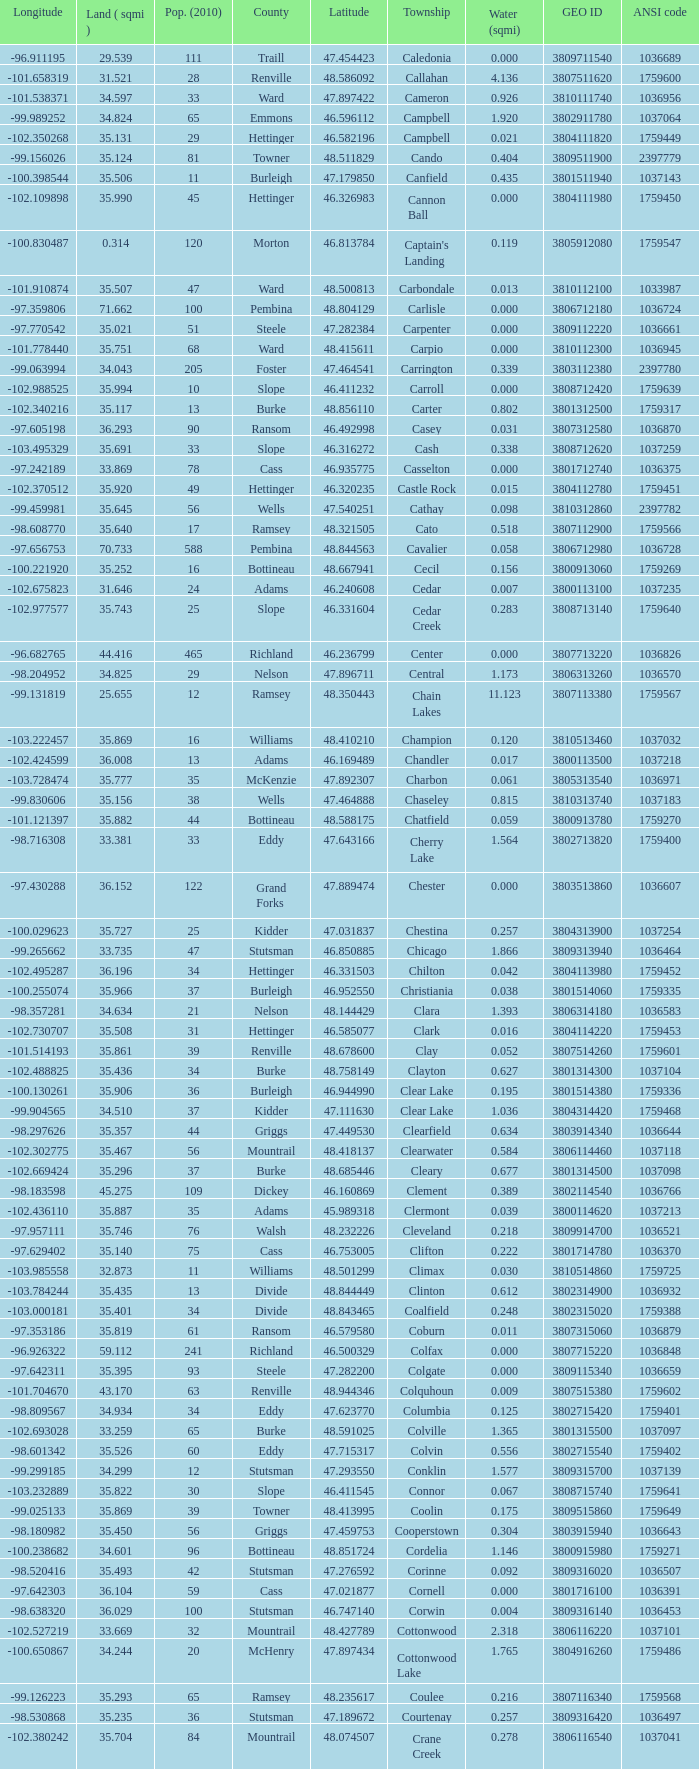What was the latitude of the Clearwater townsship? 48.418137. Can you parse all the data within this table? {'header': ['Longitude', 'Land ( sqmi )', 'Pop. (2010)', 'County', 'Latitude', 'Township', 'Water (sqmi)', 'GEO ID', 'ANSI code'], 'rows': [['-96.911195', '29.539', '111', 'Traill', '47.454423', 'Caledonia', '0.000', '3809711540', '1036689'], ['-101.658319', '31.521', '28', 'Renville', '48.586092', 'Callahan', '4.136', '3807511620', '1759600'], ['-101.538371', '34.597', '33', 'Ward', '47.897422', 'Cameron', '0.926', '3810111740', '1036956'], ['-99.989252', '34.824', '65', 'Emmons', '46.596112', 'Campbell', '1.920', '3802911780', '1037064'], ['-102.350268', '35.131', '29', 'Hettinger', '46.582196', 'Campbell', '0.021', '3804111820', '1759449'], ['-99.156026', '35.124', '81', 'Towner', '48.511829', 'Cando', '0.404', '3809511900', '2397779'], ['-100.398544', '35.506', '11', 'Burleigh', '47.179850', 'Canfield', '0.435', '3801511940', '1037143'], ['-102.109898', '35.990', '45', 'Hettinger', '46.326983', 'Cannon Ball', '0.000', '3804111980', '1759450'], ['-100.830487', '0.314', '120', 'Morton', '46.813784', "Captain's Landing", '0.119', '3805912080', '1759547'], ['-101.910874', '35.507', '47', 'Ward', '48.500813', 'Carbondale', '0.013', '3810112100', '1033987'], ['-97.359806', '71.662', '100', 'Pembina', '48.804129', 'Carlisle', '0.000', '3806712180', '1036724'], ['-97.770542', '35.021', '51', 'Steele', '47.282384', 'Carpenter', '0.000', '3809112220', '1036661'], ['-101.778440', '35.751', '68', 'Ward', '48.415611', 'Carpio', '0.000', '3810112300', '1036945'], ['-99.063994', '34.043', '205', 'Foster', '47.464541', 'Carrington', '0.339', '3803112380', '2397780'], ['-102.988525', '35.994', '10', 'Slope', '46.411232', 'Carroll', '0.000', '3808712420', '1759639'], ['-102.340216', '35.117', '13', 'Burke', '48.856110', 'Carter', '0.802', '3801312500', '1759317'], ['-97.605198', '36.293', '90', 'Ransom', '46.492998', 'Casey', '0.031', '3807312580', '1036870'], ['-103.495329', '35.691', '33', 'Slope', '46.316272', 'Cash', '0.338', '3808712620', '1037259'], ['-97.242189', '33.869', '78', 'Cass', '46.935775', 'Casselton', '0.000', '3801712740', '1036375'], ['-102.370512', '35.920', '49', 'Hettinger', '46.320235', 'Castle Rock', '0.015', '3804112780', '1759451'], ['-99.459981', '35.645', '56', 'Wells', '47.540251', 'Cathay', '0.098', '3810312860', '2397782'], ['-98.608770', '35.640', '17', 'Ramsey', '48.321505', 'Cato', '0.518', '3807112900', '1759566'], ['-97.656753', '70.733', '588', 'Pembina', '48.844563', 'Cavalier', '0.058', '3806712980', '1036728'], ['-100.221920', '35.252', '16', 'Bottineau', '48.667941', 'Cecil', '0.156', '3800913060', '1759269'], ['-102.675823', '31.646', '24', 'Adams', '46.240608', 'Cedar', '0.007', '3800113100', '1037235'], ['-102.977577', '35.743', '25', 'Slope', '46.331604', 'Cedar Creek', '0.283', '3808713140', '1759640'], ['-96.682765', '44.416', '465', 'Richland', '46.236799', 'Center', '0.000', '3807713220', '1036826'], ['-98.204952', '34.825', '29', 'Nelson', '47.896711', 'Central', '1.173', '3806313260', '1036570'], ['-99.131819', '25.655', '12', 'Ramsey', '48.350443', 'Chain Lakes', '11.123', '3807113380', '1759567'], ['-103.222457', '35.869', '16', 'Williams', '48.410210', 'Champion', '0.120', '3810513460', '1037032'], ['-102.424599', '36.008', '13', 'Adams', '46.169489', 'Chandler', '0.017', '3800113500', '1037218'], ['-103.728474', '35.777', '35', 'McKenzie', '47.892307', 'Charbon', '0.061', '3805313540', '1036971'], ['-99.830606', '35.156', '38', 'Wells', '47.464888', 'Chaseley', '0.815', '3810313740', '1037183'], ['-101.121397', '35.882', '44', 'Bottineau', '48.588175', 'Chatfield', '0.059', '3800913780', '1759270'], ['-98.716308', '33.381', '33', 'Eddy', '47.643166', 'Cherry Lake', '1.564', '3802713820', '1759400'], ['-97.430288', '36.152', '122', 'Grand Forks', '47.889474', 'Chester', '0.000', '3803513860', '1036607'], ['-100.029623', '35.727', '25', 'Kidder', '47.031837', 'Chestina', '0.257', '3804313900', '1037254'], ['-99.265662', '33.735', '47', 'Stutsman', '46.850885', 'Chicago', '1.866', '3809313940', '1036464'], ['-102.495287', '36.196', '34', 'Hettinger', '46.331503', 'Chilton', '0.042', '3804113980', '1759452'], ['-100.255074', '35.966', '37', 'Burleigh', '46.952550', 'Christiania', '0.038', '3801514060', '1759335'], ['-98.357281', '34.634', '21', 'Nelson', '48.144429', 'Clara', '1.393', '3806314180', '1036583'], ['-102.730707', '35.508', '31', 'Hettinger', '46.585077', 'Clark', '0.016', '3804114220', '1759453'], ['-101.514193', '35.861', '39', 'Renville', '48.678600', 'Clay', '0.052', '3807514260', '1759601'], ['-102.488825', '35.436', '34', 'Burke', '48.758149', 'Clayton', '0.627', '3801314300', '1037104'], ['-100.130261', '35.906', '36', 'Burleigh', '46.944990', 'Clear Lake', '0.195', '3801514380', '1759336'], ['-99.904565', '34.510', '37', 'Kidder', '47.111630', 'Clear Lake', '1.036', '3804314420', '1759468'], ['-98.297626', '35.357', '44', 'Griggs', '47.449530', 'Clearfield', '0.634', '3803914340', '1036644'], ['-102.302775', '35.467', '56', 'Mountrail', '48.418137', 'Clearwater', '0.584', '3806114460', '1037118'], ['-102.669424', '35.296', '37', 'Burke', '48.685446', 'Cleary', '0.677', '3801314500', '1037098'], ['-98.183598', '45.275', '109', 'Dickey', '46.160869', 'Clement', '0.389', '3802114540', '1036766'], ['-102.436110', '35.887', '35', 'Adams', '45.989318', 'Clermont', '0.039', '3800114620', '1037213'], ['-97.957111', '35.746', '76', 'Walsh', '48.232226', 'Cleveland', '0.218', '3809914700', '1036521'], ['-97.629402', '35.140', '75', 'Cass', '46.753005', 'Clifton', '0.222', '3801714780', '1036370'], ['-103.985558', '32.873', '11', 'Williams', '48.501299', 'Climax', '0.030', '3810514860', '1759725'], ['-103.784244', '35.435', '13', 'Divide', '48.844449', 'Clinton', '0.612', '3802314900', '1036932'], ['-103.000181', '35.401', '34', 'Divide', '48.843465', 'Coalfield', '0.248', '3802315020', '1759388'], ['-97.353186', '35.819', '61', 'Ransom', '46.579580', 'Coburn', '0.011', '3807315060', '1036879'], ['-96.926322', '59.112', '241', 'Richland', '46.500329', 'Colfax', '0.000', '3807715220', '1036848'], ['-97.642311', '35.395', '93', 'Steele', '47.282200', 'Colgate', '0.000', '3809115340', '1036659'], ['-101.704670', '43.170', '63', 'Renville', '48.944346', 'Colquhoun', '0.009', '3807515380', '1759602'], ['-98.809567', '34.934', '34', 'Eddy', '47.623770', 'Columbia', '0.125', '3802715420', '1759401'], ['-102.693028', '33.259', '65', 'Burke', '48.591025', 'Colville', '1.365', '3801315500', '1037097'], ['-98.601342', '35.526', '60', 'Eddy', '47.715317', 'Colvin', '0.556', '3802715540', '1759402'], ['-99.299185', '34.299', '12', 'Stutsman', '47.293550', 'Conklin', '1.577', '3809315700', '1037139'], ['-103.232889', '35.822', '30', 'Slope', '46.411545', 'Connor', '0.067', '3808715740', '1759641'], ['-99.025133', '35.869', '39', 'Towner', '48.413995', 'Coolin', '0.175', '3809515860', '1759649'], ['-98.180982', '35.450', '56', 'Griggs', '47.459753', 'Cooperstown', '0.304', '3803915940', '1036643'], ['-100.238682', '34.601', '96', 'Bottineau', '48.851724', 'Cordelia', '1.146', '3800915980', '1759271'], ['-98.520416', '35.493', '42', 'Stutsman', '47.276592', 'Corinne', '0.092', '3809316020', '1036507'], ['-97.642303', '36.104', '59', 'Cass', '47.021877', 'Cornell', '0.000', '3801716100', '1036391'], ['-98.638320', '36.029', '100', 'Stutsman', '46.747140', 'Corwin', '0.004', '3809316140', '1036453'], ['-102.527219', '33.669', '32', 'Mountrail', '48.427789', 'Cottonwood', '2.318', '3806116220', '1037101'], ['-100.650867', '34.244', '20', 'McHenry', '47.897434', 'Cottonwood Lake', '1.765', '3804916260', '1759486'], ['-99.126223', '35.293', '65', 'Ramsey', '48.235617', 'Coulee', '0.216', '3807116340', '1759568'], ['-98.530868', '35.235', '36', 'Stutsman', '47.189672', 'Courtenay', '0.257', '3809316420', '1036497'], ['-102.380242', '35.704', '84', 'Mountrail', '48.074507', 'Crane Creek', '0.278', '3806116540', '1037041'], ['-103.729934', '35.892', '31', 'Slope', '46.320329', 'Crawford', '0.051', '3808716620', '1037166'], ['-98.857272', '14.578', '1305', 'Ramsey', '48.075823', 'Creel', '15.621', '3807116660', '1759569'], ['-102.054883', '35.739', '27', 'McLean', '47.811011', 'Cremerville', '0.054', '3805516700', '1759530'], ['-99.155787', '35.047', '44', 'Towner', '48.667289', 'Crocus', '0.940', '3809516820', '1759650'], ['-100.685988', '36.163', '199', 'Burleigh', '47.026425', 'Crofte', '0.000', '3801516860', '1037131'], ['-100.558805', '36.208', '35', 'Burleigh', '47.026008', 'Cromwell', '0.000', '3801516900', '1037133'], ['-102.180433', '34.701', '18', 'Mountrail', '48.495946', 'Crowfoot', '1.283', '3806116980', '1037050'], ['-100.025924', '30.799', '7', 'Kidder', '46.770977', 'Crown Hill', '1.468', '3804317020', '1759469'], ['-97.732145', '35.499', '50', 'Pembina', '48.586423', 'Crystal', '0.000', '3806717100', '1036718'], ['-99.974737', '35.522', '32', 'Wells', '47.541346', 'Crystal Lake', '0.424', '3810317140', '1037152'], ['-99.529639', '35.415', '32', 'Kidder', '46.848792', 'Crystal Springs', '0.636', '3804317220', '1759470'], ['-97.860271', '35.709', '76', 'Barnes', '46.851144', 'Cuba', '0.032', '3800317300', '1036409'], ['-98.997611', '34.878', '26', 'Stutsman', '46.746853', 'Cusator', '0.693', '3809317460', '1036459'], ['-101.430571', '35.898', '37', 'Bottineau', '48.763937', 'Cut Bank', '0.033', '3800917540', '1759272']]} 